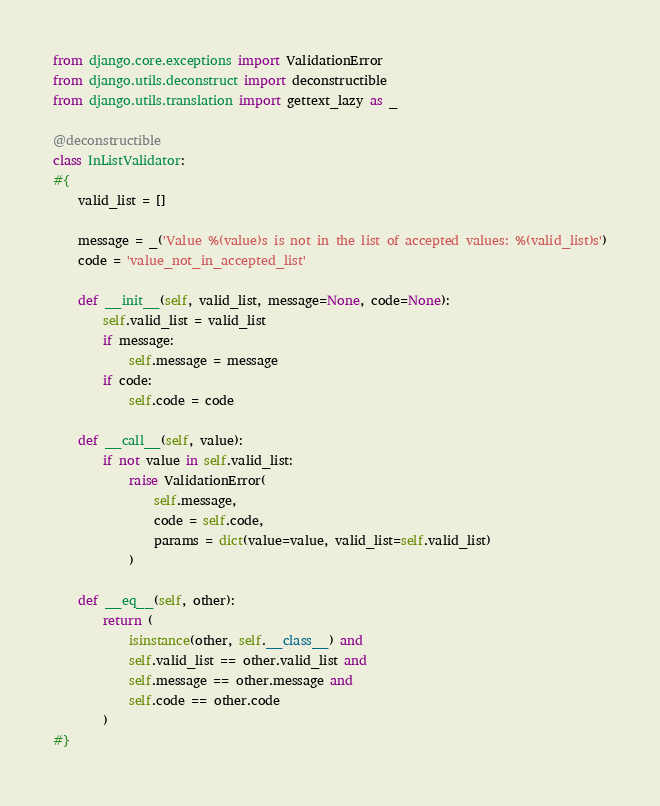Convert code to text. <code><loc_0><loc_0><loc_500><loc_500><_Python_>
from django.core.exceptions import ValidationError
from django.utils.deconstruct import deconstructible
from django.utils.translation import gettext_lazy as _

@deconstructible
class InListValidator:
#{
    valid_list = []
    
    message = _('Value %(value)s is not in the list of accepted values: %(valid_list)s')
    code = 'value_not_in_accepted_list'

    def __init__(self, valid_list, message=None, code=None):
        self.valid_list = valid_list
        if message:
            self.message = message
        if code:
            self.code = code

    def __call__(self, value):
        if not value in self.valid_list:
            raise ValidationError(
                self.message,
                code = self.code,
                params = dict(value=value, valid_list=self.valid_list)
            )

    def __eq__(self, other):
        return (
            isinstance(other, self.__class__) and
            self.valid_list == other.valid_list and
            self.message == other.message and
            self.code == other.code
        )
#}
</code> 